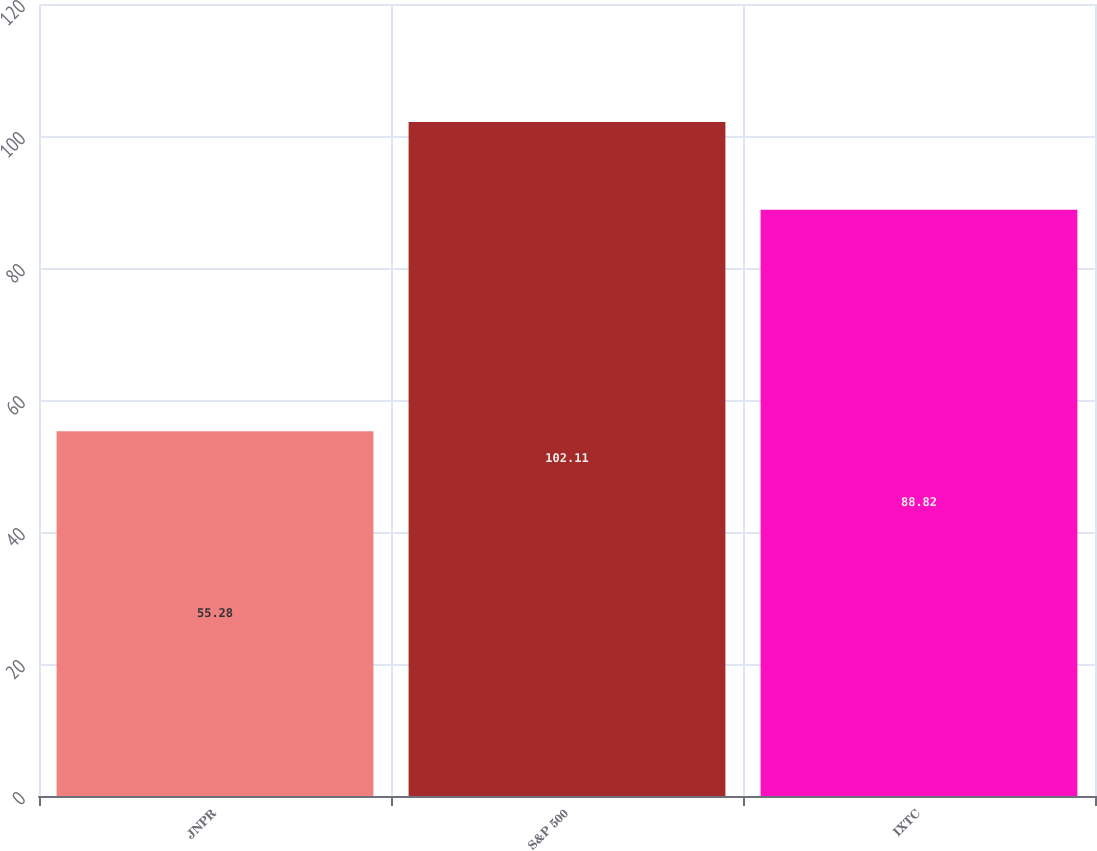<chart> <loc_0><loc_0><loc_500><loc_500><bar_chart><fcel>JNPR<fcel>S&P 500<fcel>IXTC<nl><fcel>55.28<fcel>102.11<fcel>88.82<nl></chart> 